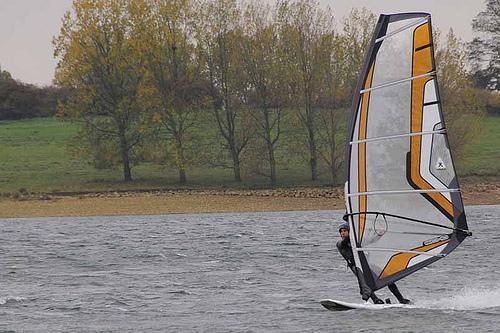How many people are there?
Give a very brief answer. 1. 